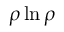<formula> <loc_0><loc_0><loc_500><loc_500>\rho \ln \rho</formula> 